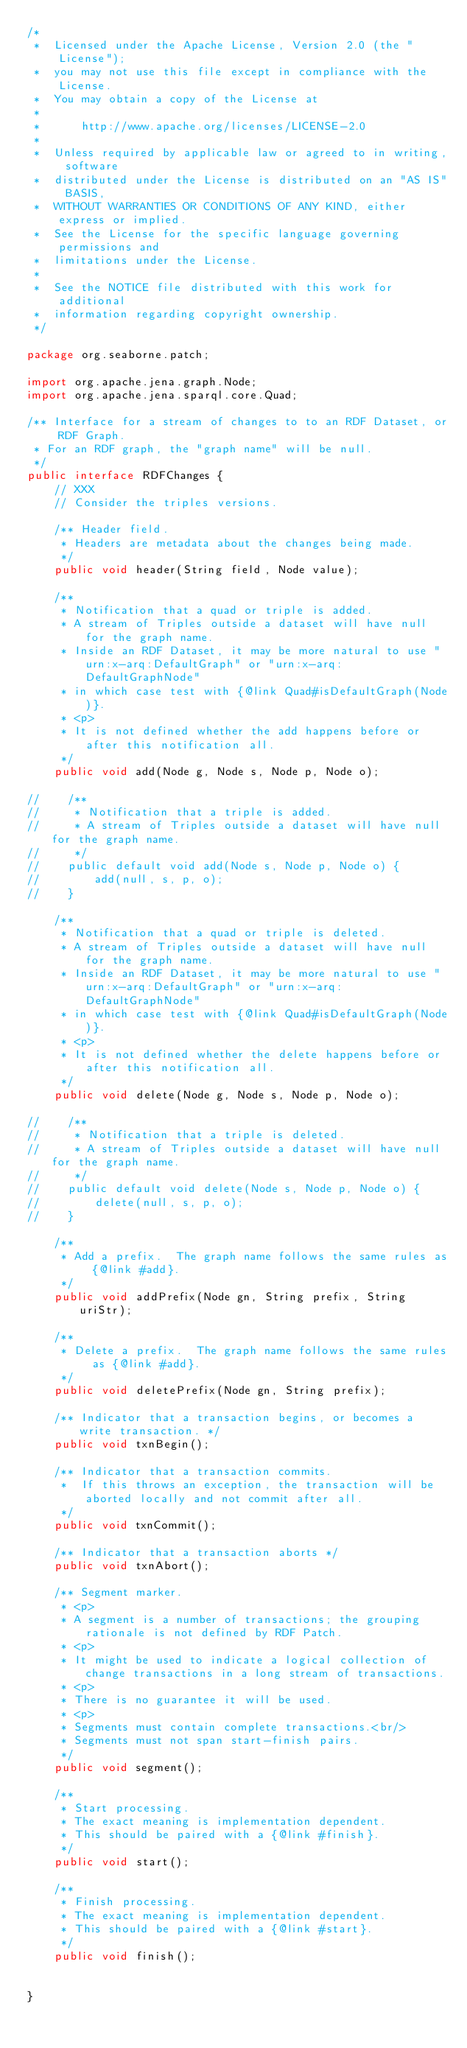<code> <loc_0><loc_0><loc_500><loc_500><_Java_>/*
 *  Licensed under the Apache License, Version 2.0 (the "License");
 *  you may not use this file except in compliance with the License.
 *  You may obtain a copy of the License at
 *
 *      http://www.apache.org/licenses/LICENSE-2.0
 *
 *  Unless required by applicable law or agreed to in writing, software
 *  distributed under the License is distributed on an "AS IS" BASIS,
 *  WITHOUT WARRANTIES OR CONDITIONS OF ANY KIND, either express or implied.
 *  See the License for the specific language governing permissions and
 *  limitations under the License.
 *
 *  See the NOTICE file distributed with this work for additional
 *  information regarding copyright ownership.
 */

package org.seaborne.patch;

import org.apache.jena.graph.Node;
import org.apache.jena.sparql.core.Quad;

/** Interface for a stream of changes to to an RDF Dataset, or RDF Graph.
 * For an RDF graph, the "graph name" will be null.
 */
public interface RDFChanges {
    // XXX
    // Consider the triples versions.

    /** Header field.
     * Headers are metadata about the changes being made.
     */
    public void header(String field, Node value);

    /**
     * Notification that a quad or triple is added.
     * A stream of Triples outside a dataset will have null for the graph name.
     * Inside an RDF Dataset, it may be more natural to use "urn:x-arq:DefaultGraph" or "urn:x-arq:DefaultGraphNode"
     * in which case test with {@link Quad#isDefaultGraph(Node)}.
     * <p>
     * It is not defined whether the add happens before or after this notification all.
     */
    public void add(Node g, Node s, Node p, Node o);

//    /**
//     * Notification that a triple is added.
//     * A stream of Triples outside a dataset will have null for the graph name.
//     */
//    public default void add(Node s, Node p, Node o) {
//        add(null, s, p, o);
//    }

    /**
     * Notification that a quad or triple is deleted.
     * A stream of Triples outside a dataset will have null for the graph name.
     * Inside an RDF Dataset, it may be more natural to use "urn:x-arq:DefaultGraph" or "urn:x-arq:DefaultGraphNode"
     * in which case test with {@link Quad#isDefaultGraph(Node)}.
     * <p>
     * It is not defined whether the delete happens before or after this notification all.
     */
    public void delete(Node g, Node s, Node p, Node o);

//    /**
//     * Notification that a triple is deleted.
//     * A stream of Triples outside a dataset will have null for the graph name.
//     */
//    public default void delete(Node s, Node p, Node o) {
//        delete(null, s, p, o);
//    }

    /**
     * Add a prefix.  The graph name follows the same rules as {@link #add}.
     */
    public void addPrefix(Node gn, String prefix, String uriStr);

    /**
     * Delete a prefix.  The graph name follows the same rules as {@link #add}.
     */
    public void deletePrefix(Node gn, String prefix);

    /** Indicator that a transaction begins, or becomes a write transaction. */
    public void txnBegin();

    /** Indicator that a transaction commits.
     *  If this throws an exception, the transaction will be aborted locally and not commit after all.
     */
    public void txnCommit();

    /** Indicator that a transaction aborts */
    public void txnAbort();

    /** Segment marker.
     * <p>
     * A segment is a number of transactions; the grouping rationale is not defined by RDF Patch.
     * <p>
     * It might be used to indicate a logical collection of change transactions in a long stream of transactions.
     * <p>
     * There is no guarantee it will be used.
     * <p>
     * Segments must contain complete transactions.<br/>
     * Segments must not span start-finish pairs.
     */
    public void segment();

    /**
     * Start processing.
     * The exact meaning is implementation dependent.
     * This should be paired with a {@link #finish}.
     */
    public void start();

    /**
     * Finish processing.
     * The exact meaning is implementation dependent.
     * This should be paired with a {@link #start}.
     */
    public void finish();


}
</code> 